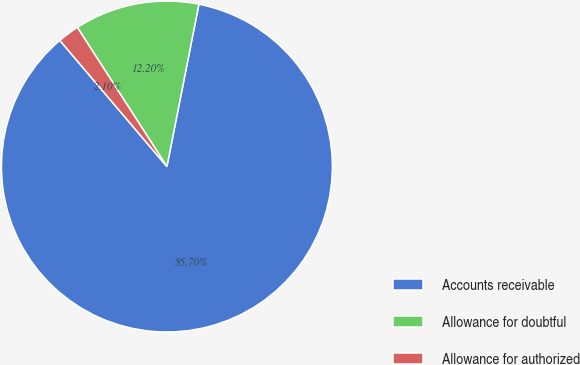<chart> <loc_0><loc_0><loc_500><loc_500><pie_chart><fcel>Accounts receivable<fcel>Allowance for doubtful<fcel>Allowance for authorized<nl><fcel>85.7%<fcel>12.2%<fcel>2.1%<nl></chart> 